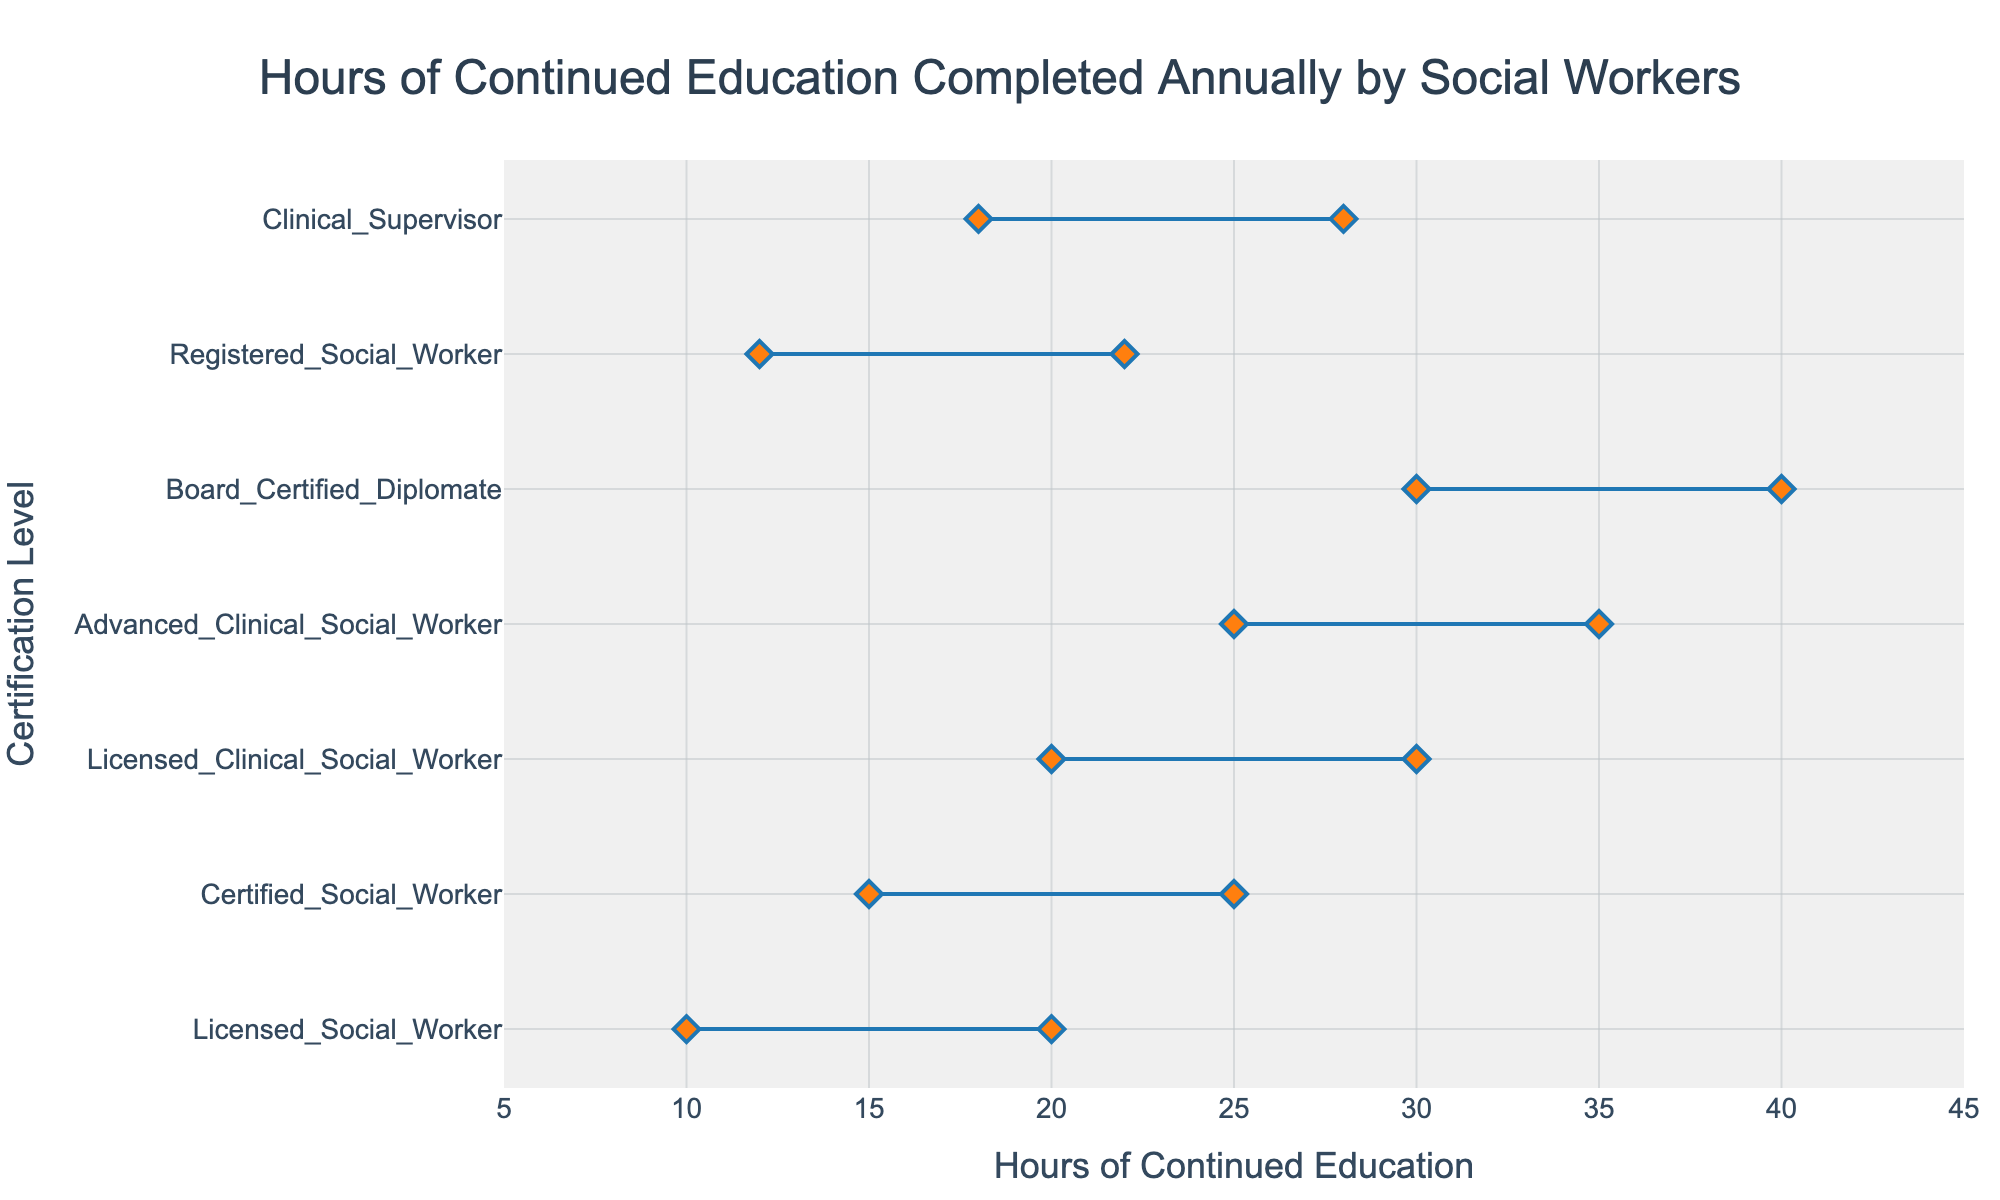How many certification levels are represented in the plot? The plot shows each certification level along the y-axis. Count the number of unique certification levels listed.
Answer: 7 What is the title of the figure? Read the text displayed at the top of the figure.
Answer: Hours of Continued Education Completed Annually by Social Workers Which certification level has the widest range of hours completed annually? Identify the certification level with the largest distance between its min and max hours.
Answer: Board Certified Diplomate What is the minimum number of hours completed annually by a Registered Social Worker? Look at the leftmost point (smallest value) on the line corresponding to Registered Social Worker on the y-axis.
Answer: 12 How many more hours of continued education does an Advanced Clinical Social Worker complete annually compared to a Licensed Social Worker at their minimum levels? Subtract the minimum hours for Licensed Social Worker from the minimum hours for Advanced Clinical Social Worker (25 - 10).
Answer: 15 Which certification level has the smallest range of hours? Identify the certification level with the smallest distance between its min and max hours.
Answer: Licensed Clinical Social Worker What is the average minimum number of hours required for a Licensed Clinical Social Worker and a Clinical Supervisor? Add the minimum hours for both positions and divide by 2 ((20 + 18) / 2).
Answer: 19 Which certification level has a maximum number of hours completed annually that is closest to 30 hours? Look at the maximum hours for each certification level and find the one closest to 30.
Answer: Licensed Clinical Social Worker How many certification levels require a maximum of 25 or fewer hours of continued education annually? Count the number of certification levels with max hours 25 or less.
Answer: 2 Is the range of hours for a Certified Social Worker greater than that for a Registered Social Worker? Compare the ranges by subtracting the minimum from the maximum for each level (Certified: 25-15 = 10, Registered: 22-12 = 10). They are equal.
Answer: No 